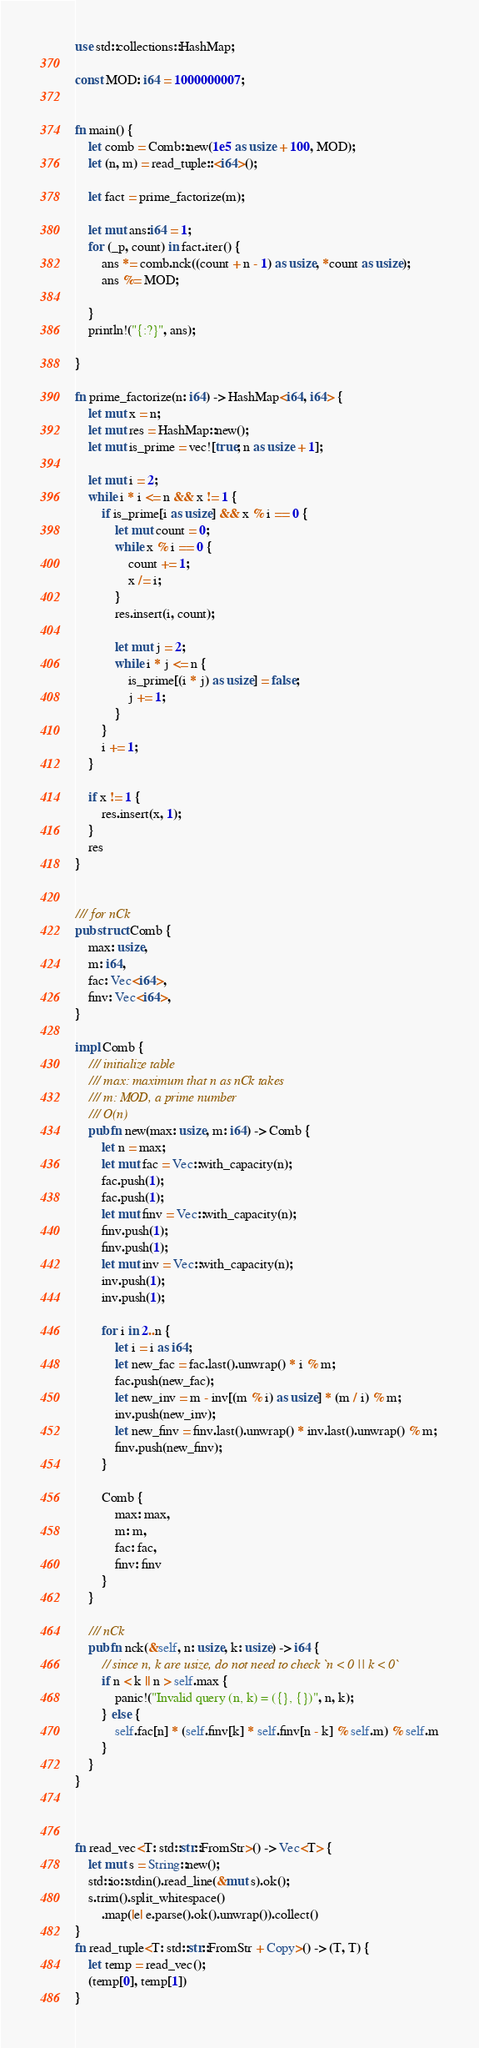Convert code to text. <code><loc_0><loc_0><loc_500><loc_500><_Rust_>use std::collections::HashMap;

const MOD: i64 = 1000000007;


fn main() {
    let comb = Comb::new(1e5 as usize + 100, MOD);
    let (n, m) = read_tuple::<i64>();

    let fact = prime_factorize(m);

    let mut ans:i64 = 1;
    for (_p, count) in fact.iter() {
        ans *= comb.nck((count + n - 1) as usize, *count as usize);
        ans %= MOD;

    }
    println!("{:?}", ans);

}

fn prime_factorize(n: i64) -> HashMap<i64, i64> {
    let mut x = n;
    let mut res = HashMap::new();
    let mut is_prime = vec![true; n as usize + 1];

    let mut i = 2;
    while i * i <= n && x != 1 {
        if is_prime[i as usize] && x % i == 0 {
            let mut count = 0;
            while x % i == 0 {
                count += 1;
                x /= i;
            }
            res.insert(i, count);

            let mut j = 2;
            while i * j <= n {
                is_prime[(i * j) as usize] = false;
                j += 1;
            }
        }
        i += 1;
    }

    if x != 1 {
        res.insert(x, 1);
    }
    res
}


/// for nCk
pub struct Comb {
    max: usize,
    m: i64,
    fac: Vec<i64>,
    finv: Vec<i64>,
}

impl Comb {
    /// initialize table 
    /// max: maximum that n as nCk takes
    /// m: MOD, a prime number
    /// O(n)
    pub fn new(max: usize, m: i64) -> Comb {
        let n = max;
        let mut fac = Vec::with_capacity(n);
        fac.push(1);
        fac.push(1);
        let mut finv = Vec::with_capacity(n);
        finv.push(1);
        finv.push(1);
        let mut inv = Vec::with_capacity(n);
        inv.push(1);
        inv.push(1);

        for i in 2..n {
            let i = i as i64;
            let new_fac = fac.last().unwrap() * i % m;
            fac.push(new_fac);
            let new_inv = m - inv[(m % i) as usize] * (m / i) % m;
            inv.push(new_inv);
            let new_finv = finv.last().unwrap() * inv.last().unwrap() % m;
            finv.push(new_finv);
        }

        Comb {
            max: max,
            m: m,
            fac: fac,
            finv: finv
        }
    }

    /// nCk
    pub fn nck(&self, n: usize, k: usize) -> i64 {
        // since n, k are usize, do not need to check `n < 0 || k < 0`
        if n < k || n > self.max {
            panic!("Invalid query (n, k) = ({}, {})", n, k);
        } else {
            self.fac[n] * (self.finv[k] * self.finv[n - k] % self.m) % self.m
        }
    }
}



fn read_vec<T: std::str::FromStr>() -> Vec<T> {
    let mut s = String::new();
    std::io::stdin().read_line(&mut s).ok();
    s.trim().split_whitespace()
        .map(|e| e.parse().ok().unwrap()).collect()
}
fn read_tuple<T: std::str::FromStr + Copy>() -> (T, T) {
    let temp = read_vec();
    (temp[0], temp[1])
}
</code> 